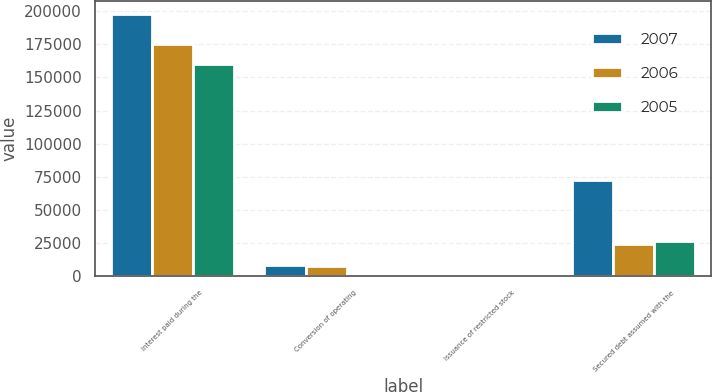Convert chart to OTSL. <chart><loc_0><loc_0><loc_500><loc_500><stacked_bar_chart><ecel><fcel>Interest paid during the<fcel>Conversion of operating<fcel>Issuance of restricted stock<fcel>Secured debt assumed with the<nl><fcel>2007<fcel>197722<fcel>8790<fcel>1<fcel>72680<nl><fcel>2006<fcel>174871<fcel>7988<fcel>3<fcel>24512<nl><fcel>2005<fcel>160367<fcel>1444<fcel>350<fcel>26825<nl></chart> 